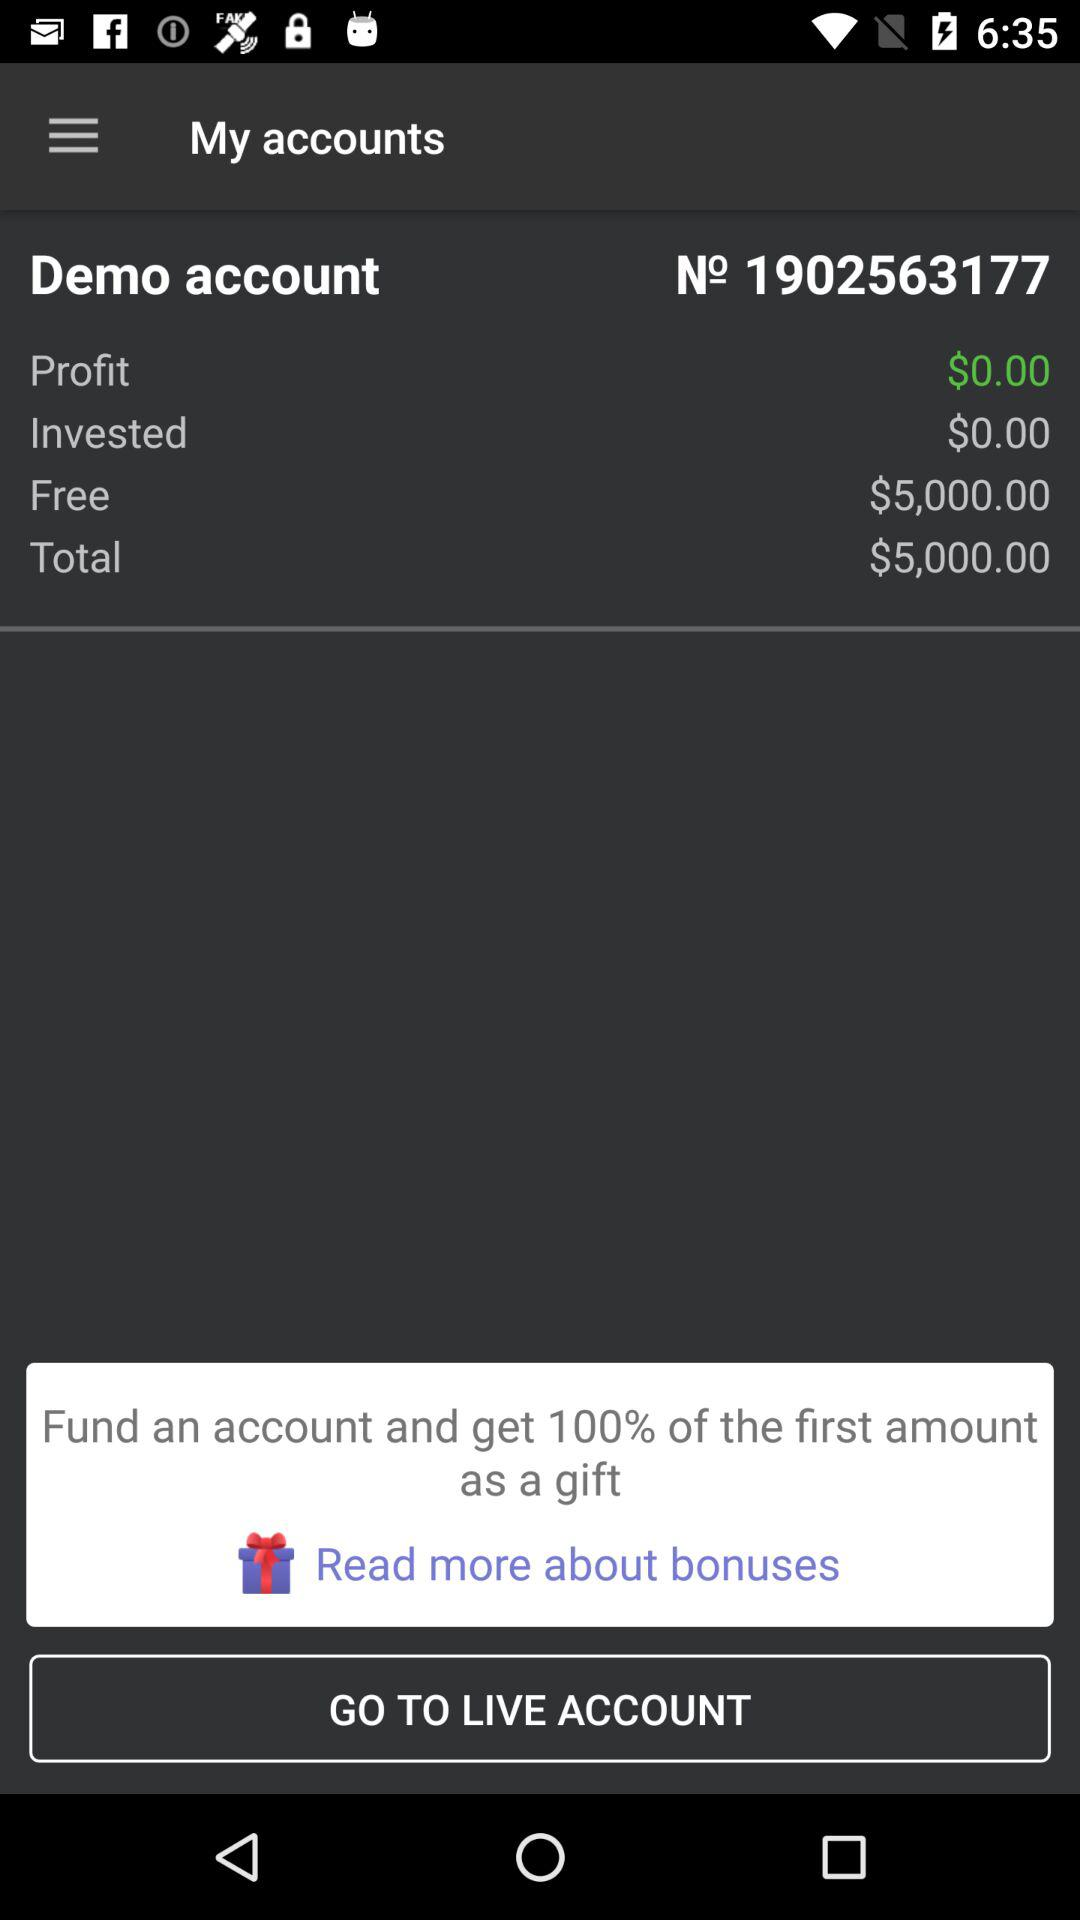What is the invested amount? The invested amount is $0.00. 